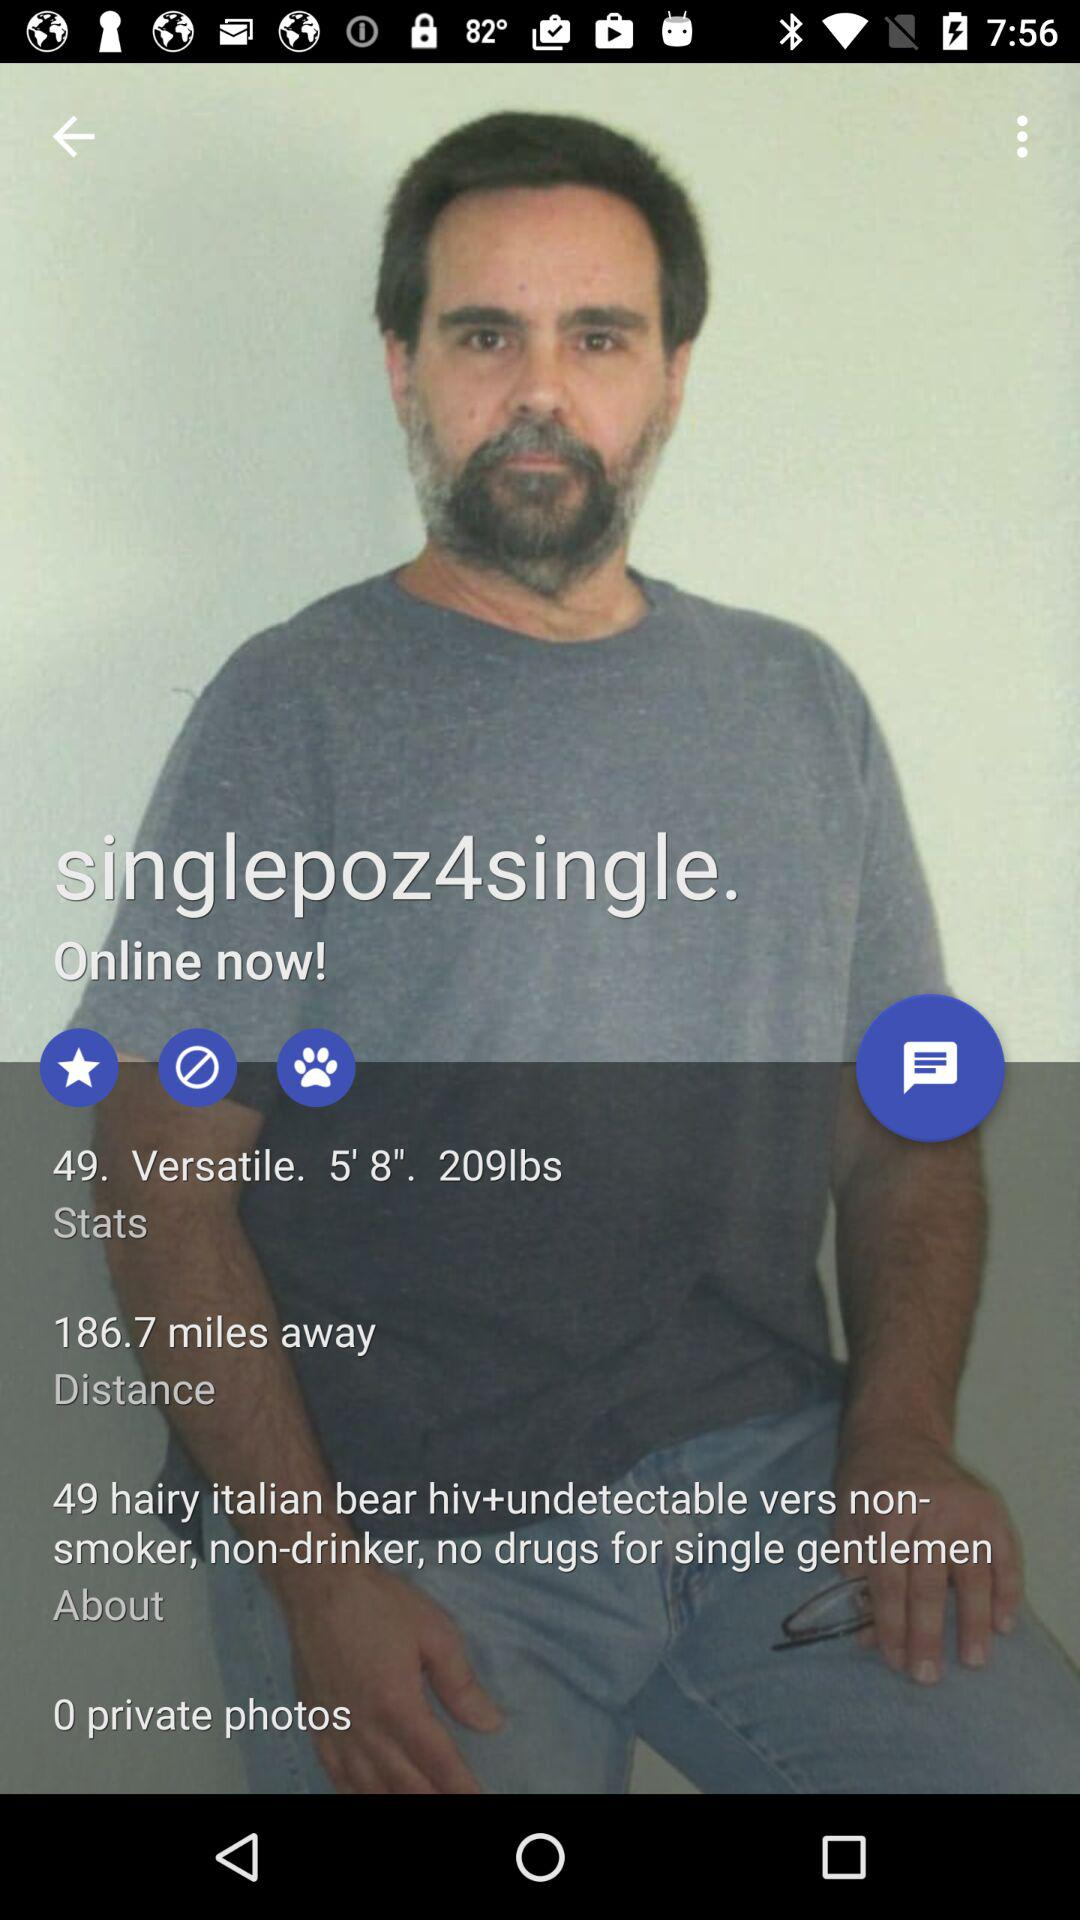What is the weight of the man? The weight of the man is 209 pounds. 